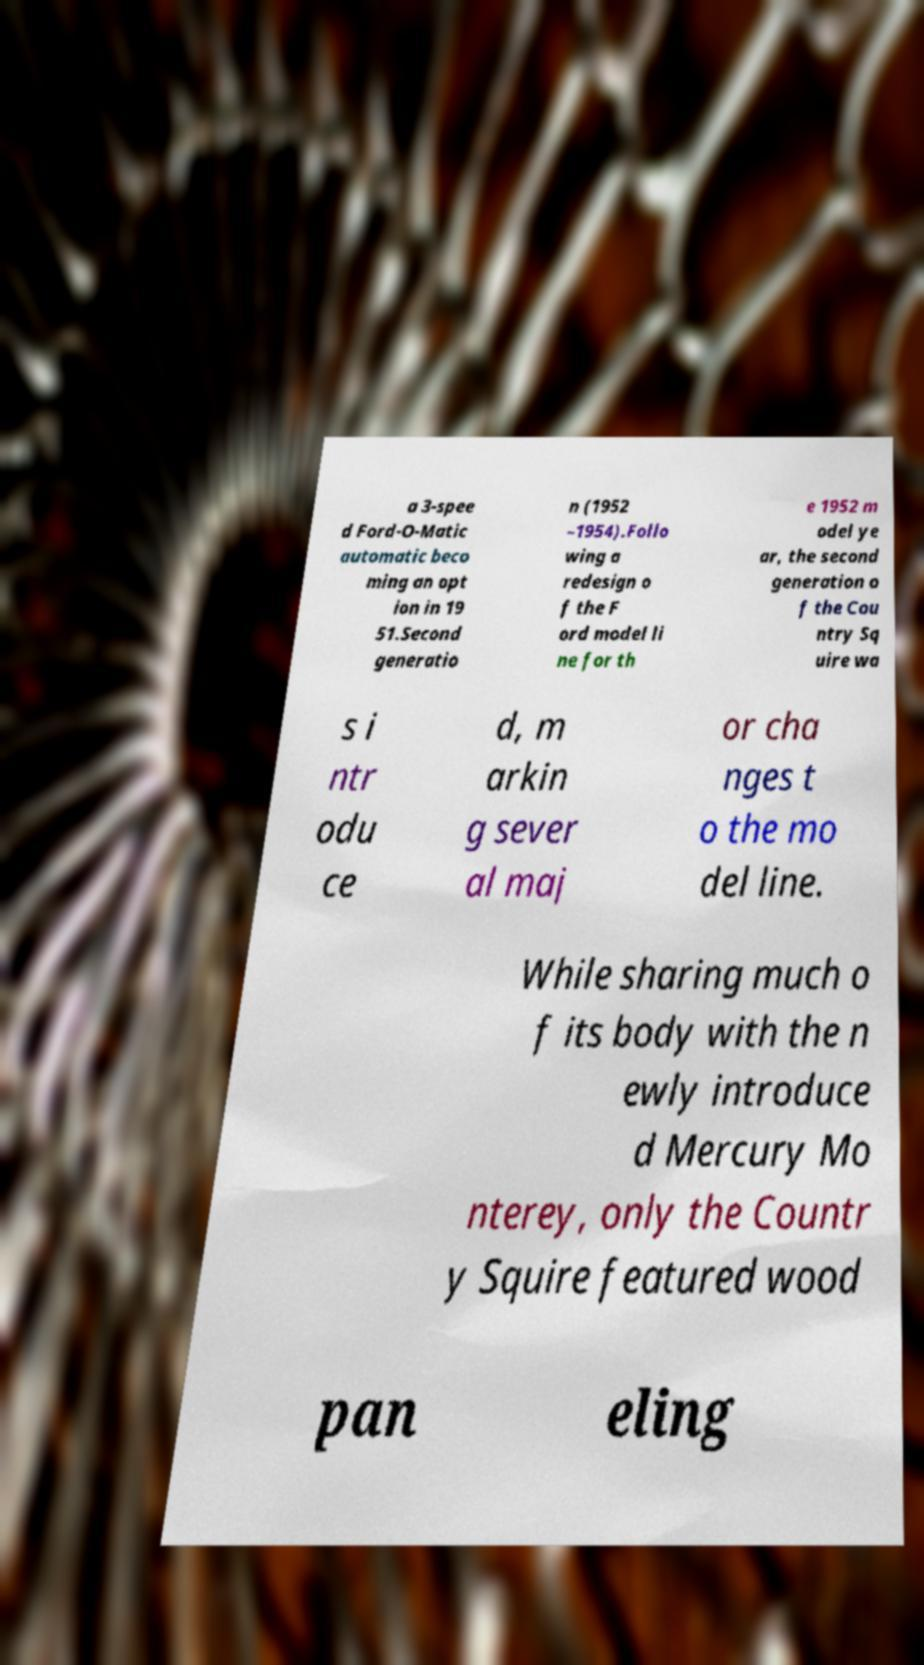Can you read and provide the text displayed in the image?This photo seems to have some interesting text. Can you extract and type it out for me? a 3-spee d Ford-O-Matic automatic beco ming an opt ion in 19 51.Second generatio n (1952 –1954).Follo wing a redesign o f the F ord model li ne for th e 1952 m odel ye ar, the second generation o f the Cou ntry Sq uire wa s i ntr odu ce d, m arkin g sever al maj or cha nges t o the mo del line. While sharing much o f its body with the n ewly introduce d Mercury Mo nterey, only the Countr y Squire featured wood pan eling 